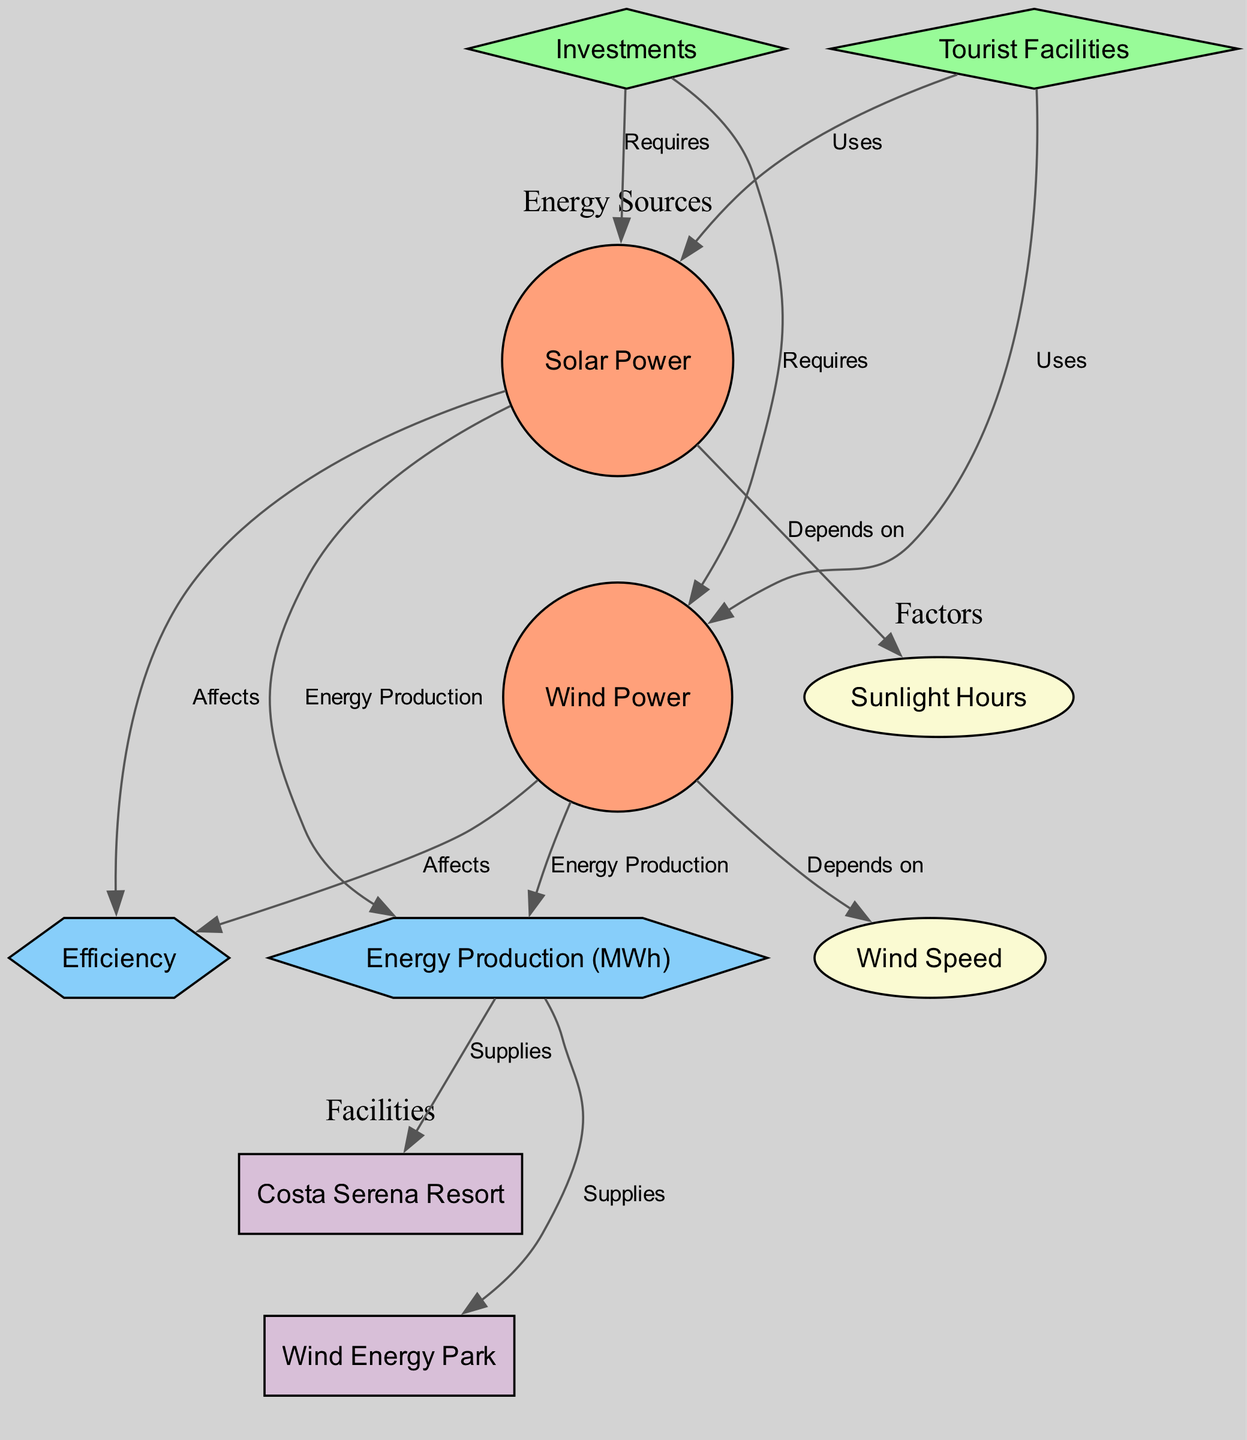What are the two energy sources mentioned in the diagram? The diagram lists 'Solar Power' and 'Wind Power' as the two main energy sources utilized in Corsican tourist facilities.
Answer: Solar Power, Wind Power How many nodes are present in the diagram? By counting the entities depicted in the diagram, there are 9 nodes: Solar Power, Wind Power, Tourist Facilities, Investments, Efficiency, Sunlight Hours, Wind Speed, Energy Production, Costa Serena Resort, and Wind Energy Park.
Answer: 9 Which tourist facility is supplied by energy production? The diagram indicates that 'Costa Serena Resort' receives energy from energy production, as represented in the edge connecting these two nodes.
Answer: Costa Serena Resort What do investments affect regarding energy sources? The edges from 'investments' to both 'solar power' and 'wind power' indicate that investments are required for both energy sources. Therefore, they are affected by investments.
Answer: Solar Power, Wind Power Which energy source depends on sunlight hours? There is a direct edge from 'solar power' to 'sunlight hours', indicating that solar power generation is dependent on the availability of sunlight hours.
Answer: Solar Power What shape represents the efficiency node in the diagram? The elevation of the efficiency node is represented with a hexagon shape according to the designation in the graphical layout of the diagram.
Answer: Hexagon Which factor is associated with wind power? The diagram illustrates a connection from 'wind power' to 'wind speed', establishing wind speed as a critical factor influencing wind power generation.
Answer: Wind Speed How does solar power affect energy production? The diagram identifies that the 'solar power' node is connected to 'energy production' through an edge labeled 'Energy Production', indicating that solar power contributes to the overall energy output.
Answer: Energy Production What does the edge labeled 'Supplies' connect to energy production? The edge labeled 'Supplies' directly connects 'energy production' to both 'Costa Serena Resort' and 'Wind Energy Park', indicating where the produced energy is utilized.
Answer: Costa Serena Resort, Wind Energy Park 